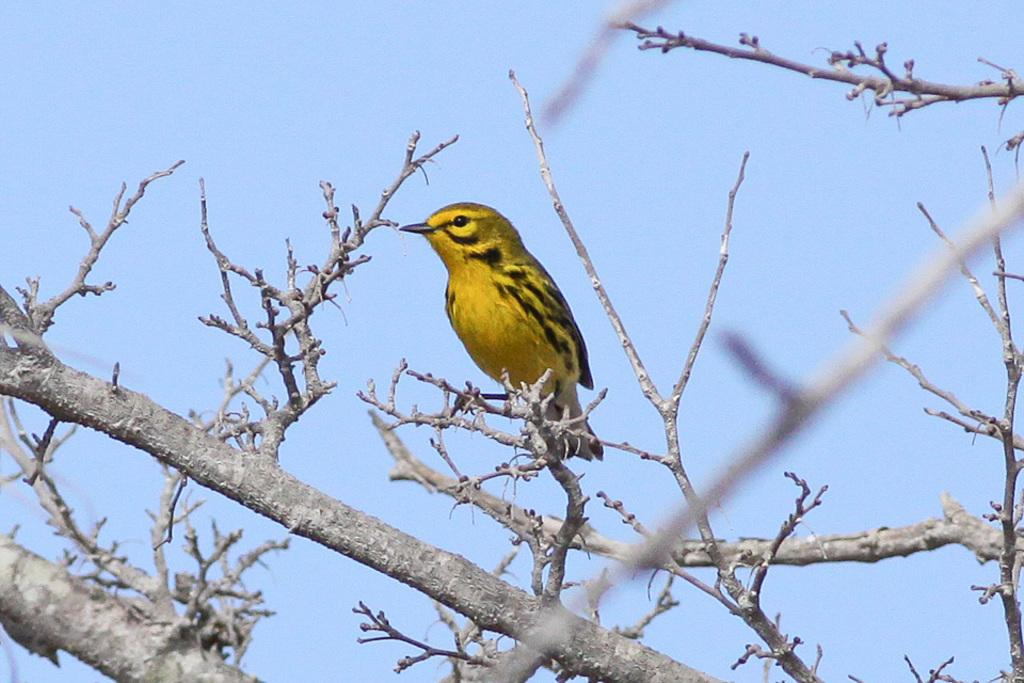What is the main object in the image? There is a tree in the image. Can you describe the bird in the image? A bird is present on a branch of the tree. What can be seen in the background of the image? The sky is visible in the background of the image. What type of slope can be seen in the image? There is no slope present in the image; it features a tree with a bird on a branch and a visible sky in the background. 